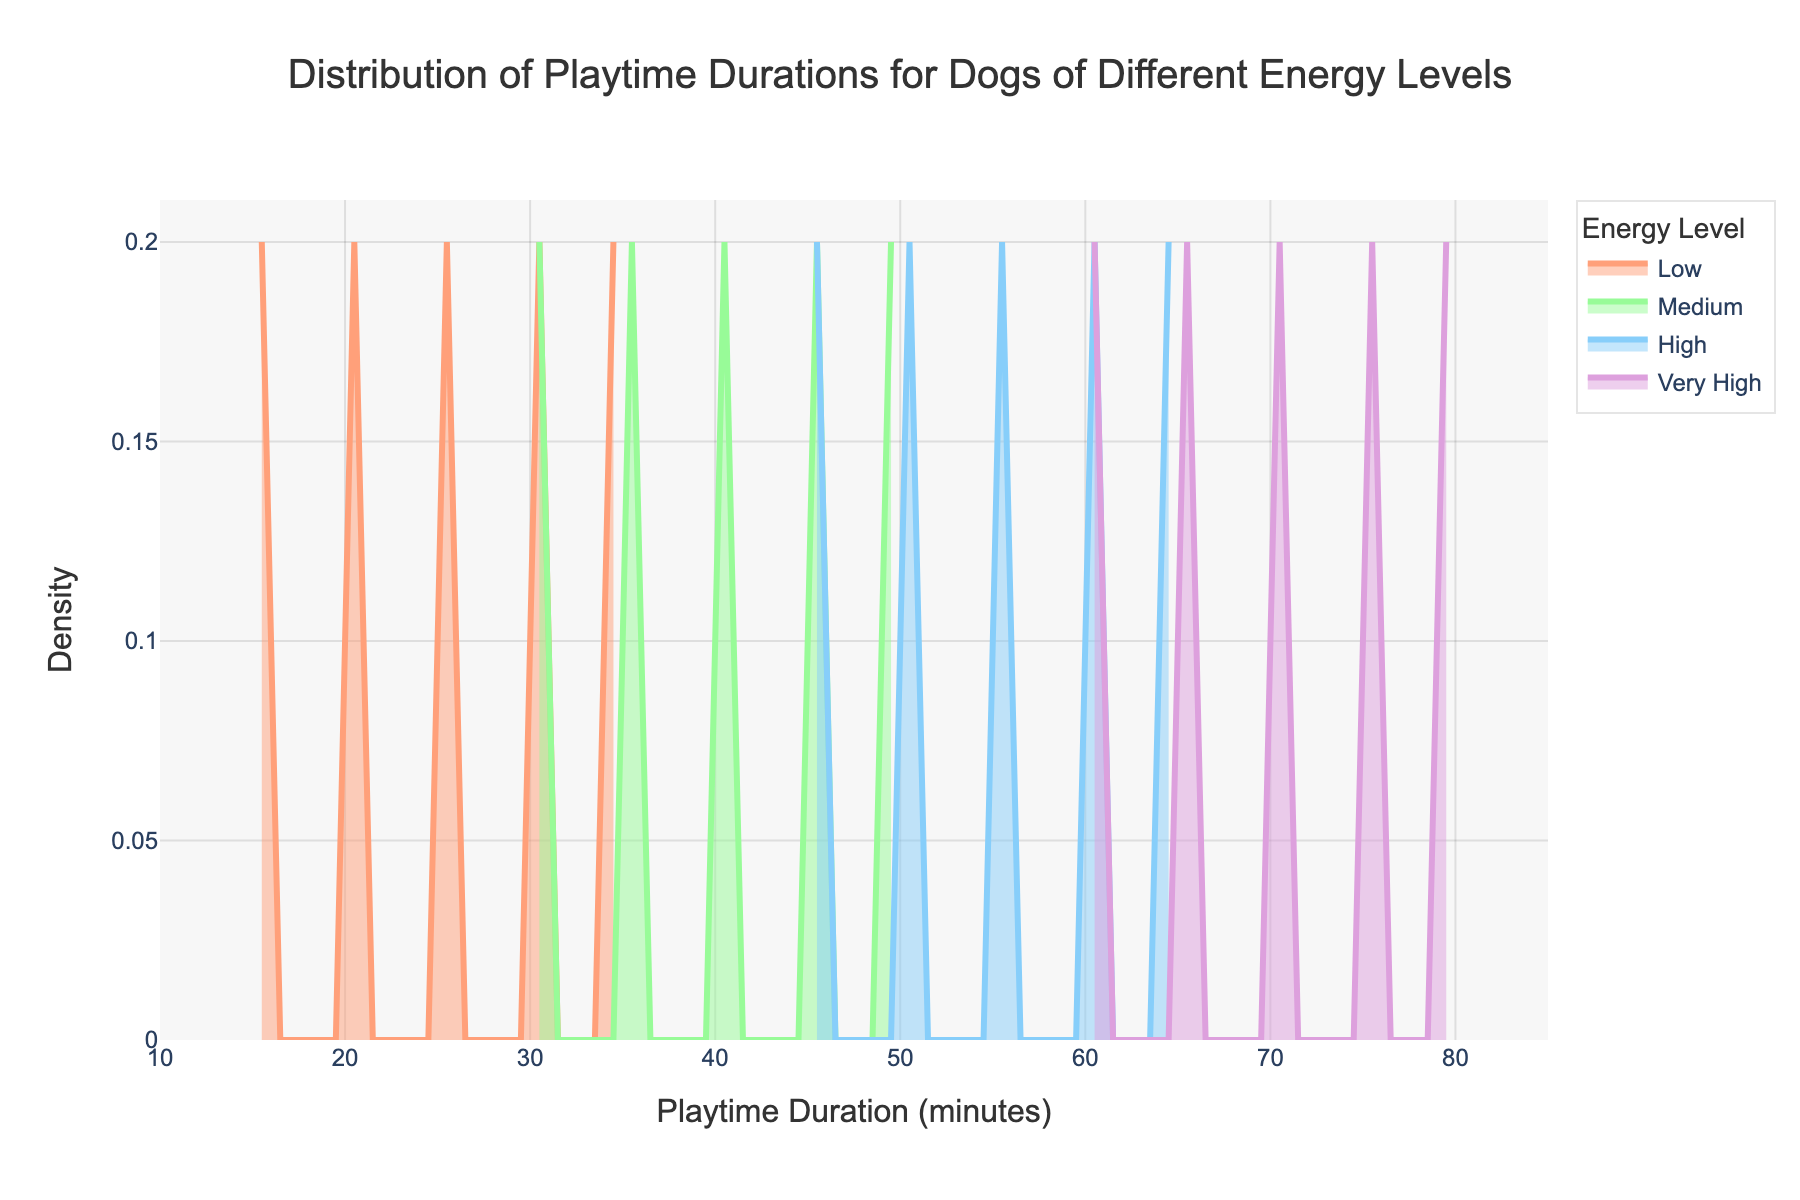What is the title of the figure? The title of the figure is located at the top and it describes the main subject of the plot. It reads "Distribution of Playtime Durations for Dogs of Different Energy Levels".
Answer: Distribution of Playtime Durations for Dogs of Different Energy Levels What do the x-axis and y-axis represent? The x-axis title reads "Playtime Duration (minutes)", indicating it represents the duration of playtime in minutes. The y-axis title reads "Density", indicating it represents the density of distribution for playtime durations.
Answer: Playtime Duration (minutes) and Density Which energy level has the highest peak density? To determine the highest peak density, observe the tallest peak within the density plot for each energy level. The tallest peak is for the "Low" energy level.
Answer: Low What range of playtime duration is covered in the plot? The x-axis range shows the coverage from just below 10 to slightly above 80 minutes, as seen on the plot.
Answer: 10 to 85 minutes Between 'High' and 'Very High' energy levels, which one has a wider spread of playtime durations? The spread of playtime duration is indicated by the width of the density curves. The 'Very High' energy level has a wider range compared to the 'High' energy level, as it stretches further from 60 to 80 minutes.
Answer: Very High How does the playtime duration of 'Low' energy level dogs compare with that of 'Medium' energy level dogs? 'Low' energy level dogs have shorter playtime durations, peaking around 20-40 minutes, while 'Medium' energy level dogs have durations peaking around 35-50 minutes, i.e., longer durations on average.
Answer: Low energy level dogs have shorter playtime durations than Medium energy level dogs What is the approximate playtime duration at which 'Medium' energy level dogs reach their peak density? For 'Medium' energy level dogs, the peak density occurs at approximately 40 minutes, shown by the highest point on the 'Medium' density curve.
Answer: 40 minutes Are the density plots for different energy levels overlapping? Observing the density plots, the curves representing different energy levels show overlappings at various points, indicating shared ranges in playtime durations.
Answer: Yes Which energy level's peak density is closest to a playtime duration of 50 minutes? The peak density curve closest to 50 minutes belongs to the 'High' energy level, as its peak lies near the 50-minute mark.
Answer: High 